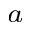Convert formula to latex. <formula><loc_0><loc_0><loc_500><loc_500>^ { a }</formula> 